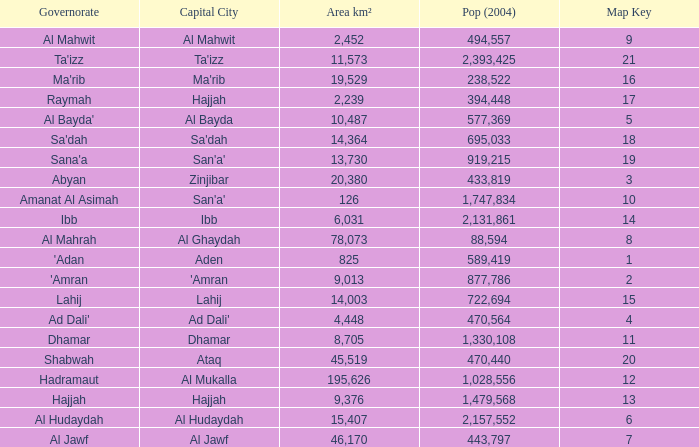Count the sum of Pop (2004) which has a Governorate of al mahrah with an Area km² smaller than 78,073? None. I'm looking to parse the entire table for insights. Could you assist me with that? {'header': ['Governorate', 'Capital City', 'Area km²', 'Pop (2004)', 'Map Key'], 'rows': [['Al Mahwit', 'Al Mahwit', '2,452', '494,557', '9'], ["Ta'izz", "Ta'izz", '11,573', '2,393,425', '21'], ["Ma'rib", "Ma'rib", '19,529', '238,522', '16'], ['Raymah', 'Hajjah', '2,239', '394,448', '17'], ["Al Bayda'", 'Al Bayda', '10,487', '577,369', '5'], ["Sa'dah", "Sa'dah", '14,364', '695,033', '18'], ["Sana'a", "San'a'", '13,730', '919,215', '19'], ['Abyan', 'Zinjibar', '20,380', '433,819', '3'], ['Amanat Al Asimah', "San'a'", '126', '1,747,834', '10'], ['Ibb', 'Ibb', '6,031', '2,131,861', '14'], ['Al Mahrah', 'Al Ghaydah', '78,073', '88,594', '8'], ["'Adan", 'Aden', '825', '589,419', '1'], ["'Amran", "'Amran", '9,013', '877,786', '2'], ['Lahij', 'Lahij', '14,003', '722,694', '15'], ["Ad Dali'", "Ad Dali'", '4,448', '470,564', '4'], ['Dhamar', 'Dhamar', '8,705', '1,330,108', '11'], ['Shabwah', 'Ataq', '45,519', '470,440', '20'], ['Hadramaut', 'Al Mukalla', '195,626', '1,028,556', '12'], ['Hajjah', 'Hajjah', '9,376', '1,479,568', '13'], ['Al Hudaydah', 'Al Hudaydah', '15,407', '2,157,552', '6'], ['Al Jawf', 'Al Jawf', '46,170', '443,797', '7']]} 